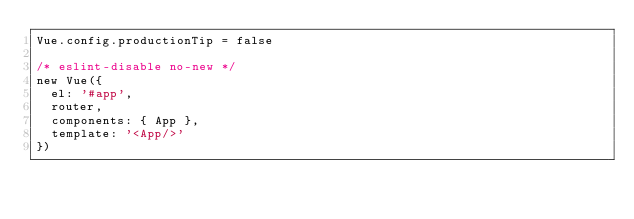Convert code to text. <code><loc_0><loc_0><loc_500><loc_500><_JavaScript_>Vue.config.productionTip = false

/* eslint-disable no-new */
new Vue({
  el: '#app',
  router,
  components: { App },
  template: '<App/>'
})
</code> 